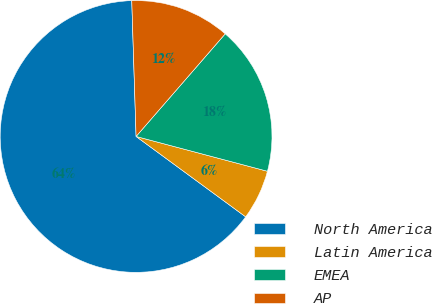Convert chart to OTSL. <chart><loc_0><loc_0><loc_500><loc_500><pie_chart><fcel>North America<fcel>Latin America<fcel>EMEA<fcel>AP<nl><fcel>64.42%<fcel>5.95%<fcel>17.74%<fcel>11.89%<nl></chart> 